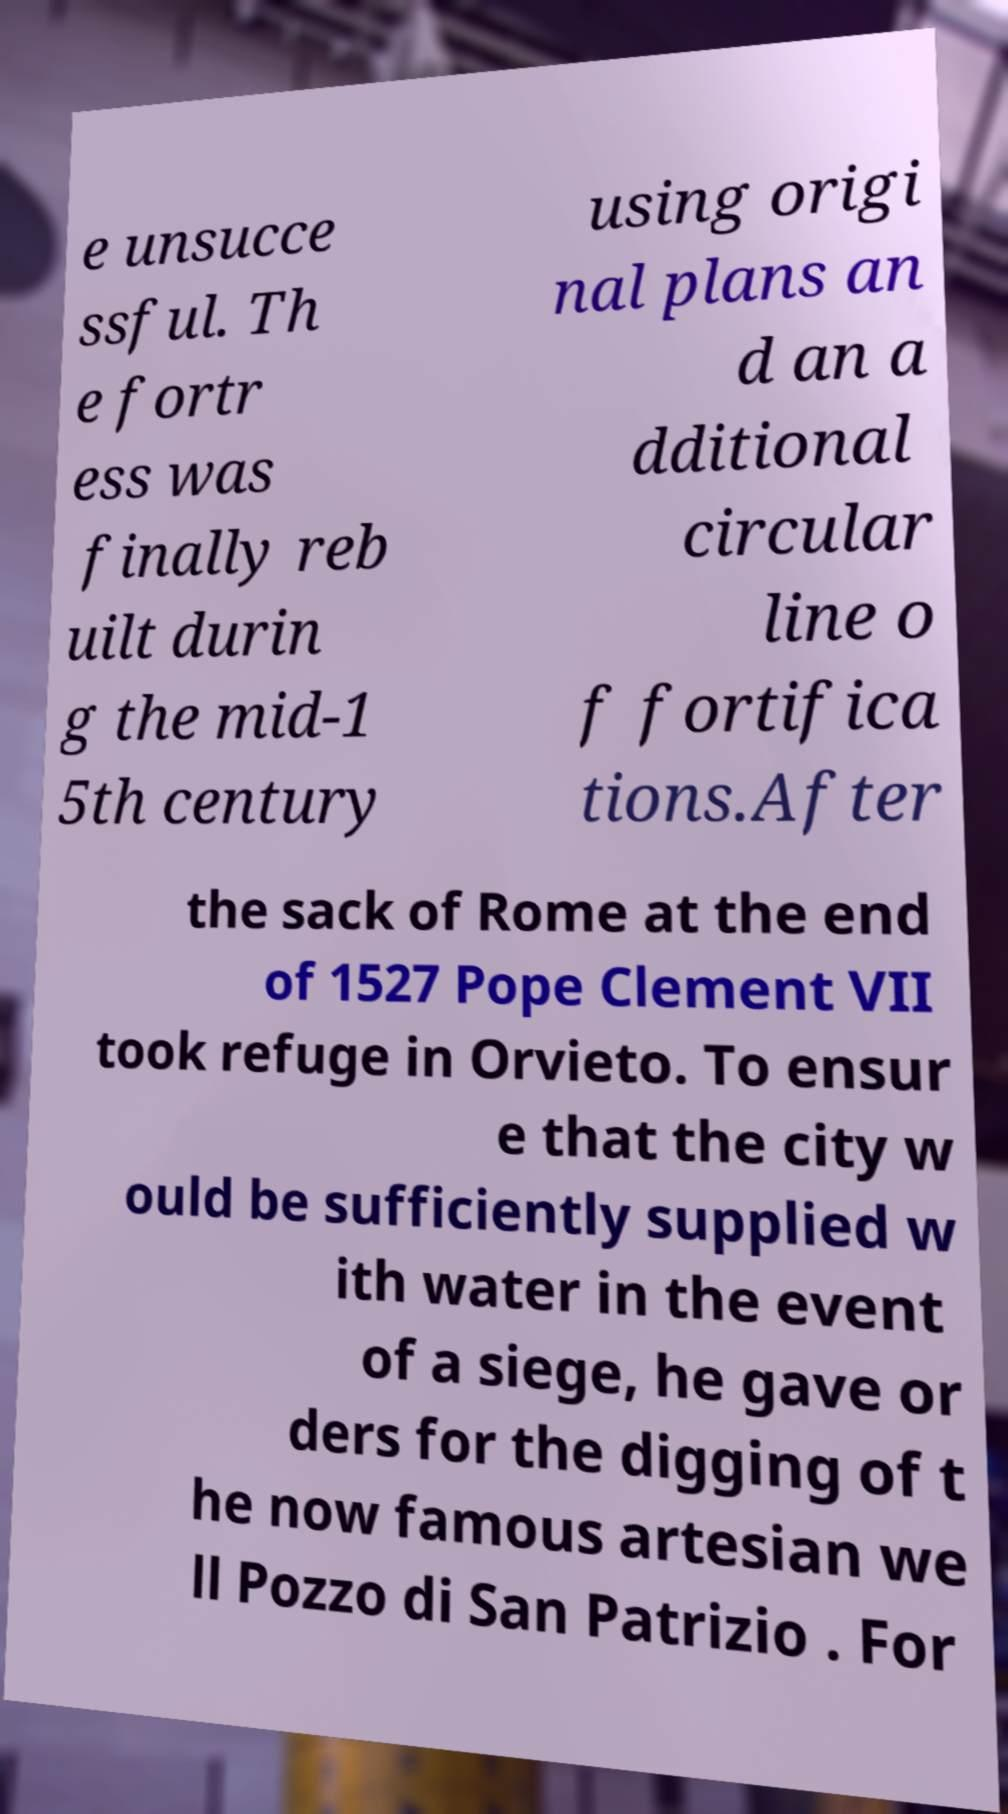For documentation purposes, I need the text within this image transcribed. Could you provide that? e unsucce ssful. Th e fortr ess was finally reb uilt durin g the mid-1 5th century using origi nal plans an d an a dditional circular line o f fortifica tions.After the sack of Rome at the end of 1527 Pope Clement VII took refuge in Orvieto. To ensur e that the city w ould be sufficiently supplied w ith water in the event of a siege, he gave or ders for the digging of t he now famous artesian we ll Pozzo di San Patrizio . For 